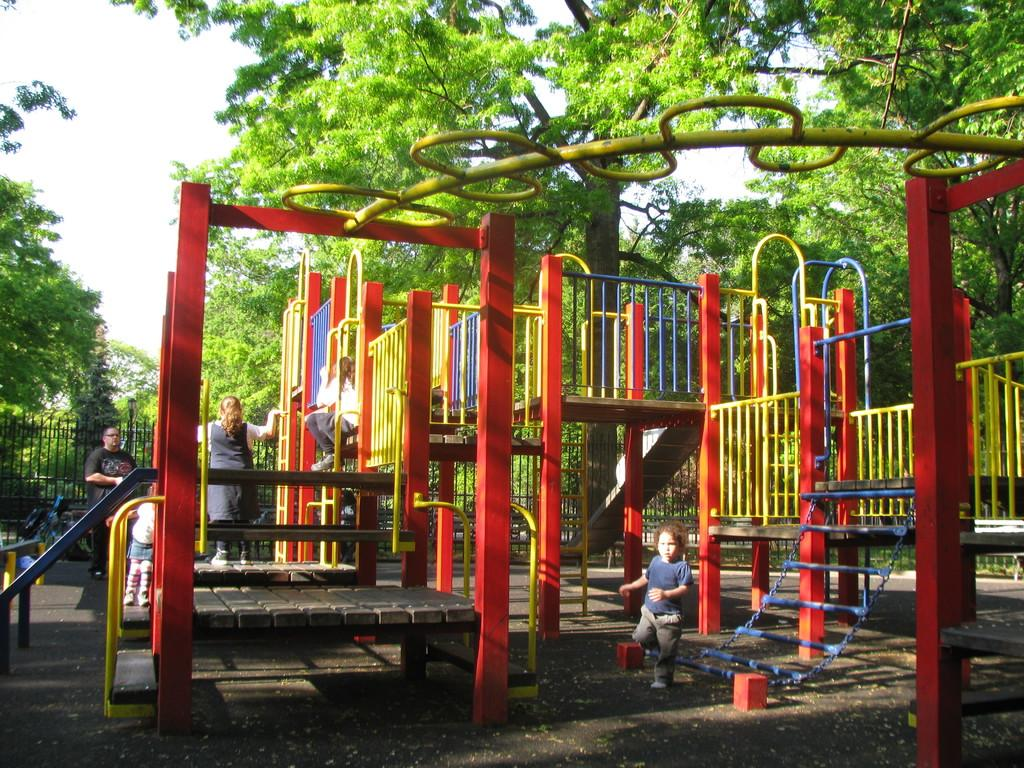What is the main focus of the image? The main focus of the image is outdoor games. Are there any people present in the image? Yes, there are people in the image. What can be seen in the background of the image? In the background of the image, there is a fence, trees, and the sky. How many apples are being held by the monkey in the image? There is no monkey or apples present in the image. Which ear is the person in the image using to listen to the music? There is no music or indication of listening in the image. 